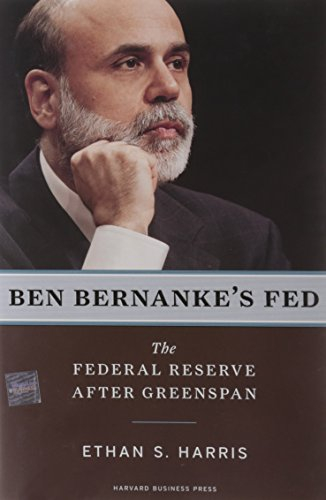Can you provide a summary of the themes discussed in this book? The book provides an analysis of Ben Bernanke's leadership of the Federal Reserve, discussing themes such as monetary policy, crisis management during financial upheavals, and the transition from Greenspan's strategies. 